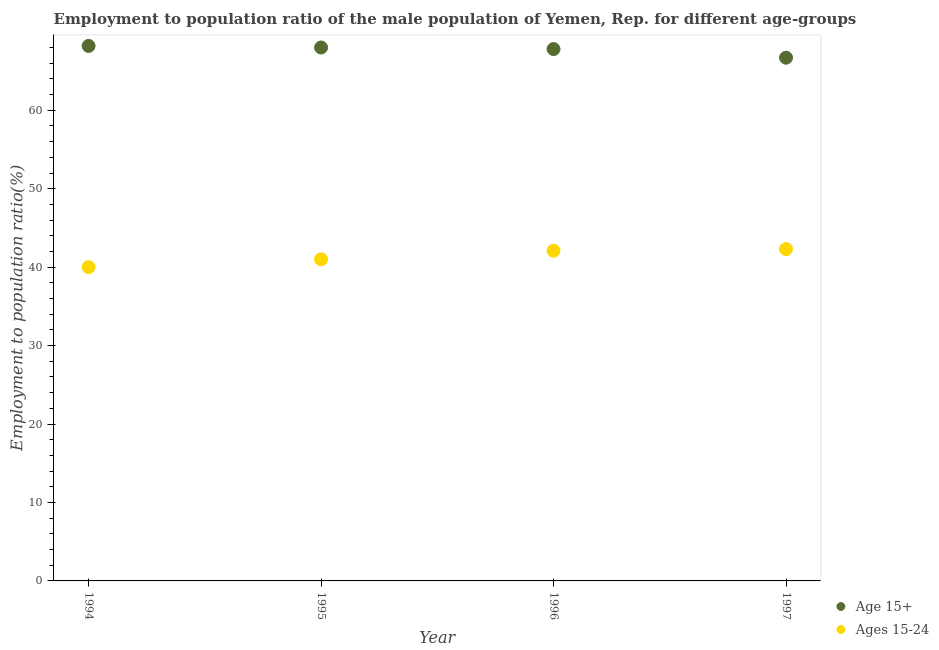What is the employment to population ratio(age 15+) in 1995?
Your answer should be compact. 68. Across all years, what is the maximum employment to population ratio(age 15+)?
Your response must be concise. 68.2. Across all years, what is the minimum employment to population ratio(age 15+)?
Provide a short and direct response. 66.7. What is the total employment to population ratio(age 15-24) in the graph?
Offer a very short reply. 165.4. What is the difference between the employment to population ratio(age 15+) in 1995 and that in 1996?
Keep it short and to the point. 0.2. What is the difference between the employment to population ratio(age 15+) in 1994 and the employment to population ratio(age 15-24) in 1995?
Offer a very short reply. 27.2. What is the average employment to population ratio(age 15-24) per year?
Give a very brief answer. 41.35. In how many years, is the employment to population ratio(age 15-24) greater than 14 %?
Make the answer very short. 4. What is the ratio of the employment to population ratio(age 15-24) in 1996 to that in 1997?
Your answer should be compact. 1. Is the employment to population ratio(age 15-24) in 1994 less than that in 1997?
Keep it short and to the point. Yes. Is the difference between the employment to population ratio(age 15-24) in 1994 and 1996 greater than the difference between the employment to population ratio(age 15+) in 1994 and 1996?
Your answer should be very brief. No. What is the difference between the highest and the second highest employment to population ratio(age 15-24)?
Ensure brevity in your answer.  0.2. What is the difference between the highest and the lowest employment to population ratio(age 15+)?
Give a very brief answer. 1.5. Is the employment to population ratio(age 15+) strictly less than the employment to population ratio(age 15-24) over the years?
Your answer should be compact. No. What is the difference between two consecutive major ticks on the Y-axis?
Keep it short and to the point. 10. Does the graph contain any zero values?
Provide a succinct answer. No. Does the graph contain grids?
Provide a succinct answer. No. What is the title of the graph?
Your answer should be compact. Employment to population ratio of the male population of Yemen, Rep. for different age-groups. Does "Highest 10% of population" appear as one of the legend labels in the graph?
Offer a terse response. No. What is the label or title of the X-axis?
Make the answer very short. Year. What is the label or title of the Y-axis?
Give a very brief answer. Employment to population ratio(%). What is the Employment to population ratio(%) of Age 15+ in 1994?
Keep it short and to the point. 68.2. What is the Employment to population ratio(%) in Ages 15-24 in 1995?
Make the answer very short. 41. What is the Employment to population ratio(%) of Age 15+ in 1996?
Keep it short and to the point. 67.8. What is the Employment to population ratio(%) of Ages 15-24 in 1996?
Provide a succinct answer. 42.1. What is the Employment to population ratio(%) in Age 15+ in 1997?
Ensure brevity in your answer.  66.7. What is the Employment to population ratio(%) of Ages 15-24 in 1997?
Ensure brevity in your answer.  42.3. Across all years, what is the maximum Employment to population ratio(%) of Age 15+?
Provide a short and direct response. 68.2. Across all years, what is the maximum Employment to population ratio(%) of Ages 15-24?
Offer a very short reply. 42.3. Across all years, what is the minimum Employment to population ratio(%) of Age 15+?
Keep it short and to the point. 66.7. Across all years, what is the minimum Employment to population ratio(%) in Ages 15-24?
Your response must be concise. 40. What is the total Employment to population ratio(%) in Age 15+ in the graph?
Offer a terse response. 270.7. What is the total Employment to population ratio(%) of Ages 15-24 in the graph?
Ensure brevity in your answer.  165.4. What is the difference between the Employment to population ratio(%) of Age 15+ in 1994 and that in 1995?
Keep it short and to the point. 0.2. What is the difference between the Employment to population ratio(%) in Age 15+ in 1994 and that in 1996?
Your response must be concise. 0.4. What is the difference between the Employment to population ratio(%) in Ages 15-24 in 1994 and that in 1996?
Your response must be concise. -2.1. What is the difference between the Employment to population ratio(%) of Age 15+ in 1994 and that in 1997?
Your answer should be compact. 1.5. What is the difference between the Employment to population ratio(%) of Age 15+ in 1995 and that in 1997?
Your answer should be very brief. 1.3. What is the difference between the Employment to population ratio(%) of Ages 15-24 in 1995 and that in 1997?
Your answer should be compact. -1.3. What is the difference between the Employment to population ratio(%) of Age 15+ in 1996 and that in 1997?
Ensure brevity in your answer.  1.1. What is the difference between the Employment to population ratio(%) of Ages 15-24 in 1996 and that in 1997?
Offer a terse response. -0.2. What is the difference between the Employment to population ratio(%) of Age 15+ in 1994 and the Employment to population ratio(%) of Ages 15-24 in 1995?
Keep it short and to the point. 27.2. What is the difference between the Employment to population ratio(%) in Age 15+ in 1994 and the Employment to population ratio(%) in Ages 15-24 in 1996?
Provide a short and direct response. 26.1. What is the difference between the Employment to population ratio(%) of Age 15+ in 1994 and the Employment to population ratio(%) of Ages 15-24 in 1997?
Offer a terse response. 25.9. What is the difference between the Employment to population ratio(%) in Age 15+ in 1995 and the Employment to population ratio(%) in Ages 15-24 in 1996?
Your answer should be compact. 25.9. What is the difference between the Employment to population ratio(%) of Age 15+ in 1995 and the Employment to population ratio(%) of Ages 15-24 in 1997?
Your response must be concise. 25.7. What is the average Employment to population ratio(%) in Age 15+ per year?
Your answer should be very brief. 67.67. What is the average Employment to population ratio(%) in Ages 15-24 per year?
Provide a succinct answer. 41.35. In the year 1994, what is the difference between the Employment to population ratio(%) in Age 15+ and Employment to population ratio(%) in Ages 15-24?
Give a very brief answer. 28.2. In the year 1996, what is the difference between the Employment to population ratio(%) of Age 15+ and Employment to population ratio(%) of Ages 15-24?
Keep it short and to the point. 25.7. In the year 1997, what is the difference between the Employment to population ratio(%) of Age 15+ and Employment to population ratio(%) of Ages 15-24?
Your answer should be compact. 24.4. What is the ratio of the Employment to population ratio(%) in Age 15+ in 1994 to that in 1995?
Give a very brief answer. 1. What is the ratio of the Employment to population ratio(%) in Ages 15-24 in 1994 to that in 1995?
Your response must be concise. 0.98. What is the ratio of the Employment to population ratio(%) of Age 15+ in 1994 to that in 1996?
Make the answer very short. 1.01. What is the ratio of the Employment to population ratio(%) of Ages 15-24 in 1994 to that in 1996?
Your answer should be compact. 0.95. What is the ratio of the Employment to population ratio(%) in Age 15+ in 1994 to that in 1997?
Make the answer very short. 1.02. What is the ratio of the Employment to population ratio(%) in Ages 15-24 in 1994 to that in 1997?
Offer a very short reply. 0.95. What is the ratio of the Employment to population ratio(%) of Ages 15-24 in 1995 to that in 1996?
Provide a succinct answer. 0.97. What is the ratio of the Employment to population ratio(%) of Age 15+ in 1995 to that in 1997?
Make the answer very short. 1.02. What is the ratio of the Employment to population ratio(%) of Ages 15-24 in 1995 to that in 1997?
Make the answer very short. 0.97. What is the ratio of the Employment to population ratio(%) in Age 15+ in 1996 to that in 1997?
Ensure brevity in your answer.  1.02. What is the ratio of the Employment to population ratio(%) in Ages 15-24 in 1996 to that in 1997?
Provide a succinct answer. 1. What is the difference between the highest and the second highest Employment to population ratio(%) in Ages 15-24?
Your answer should be very brief. 0.2. What is the difference between the highest and the lowest Employment to population ratio(%) in Age 15+?
Provide a short and direct response. 1.5. What is the difference between the highest and the lowest Employment to population ratio(%) of Ages 15-24?
Offer a terse response. 2.3. 